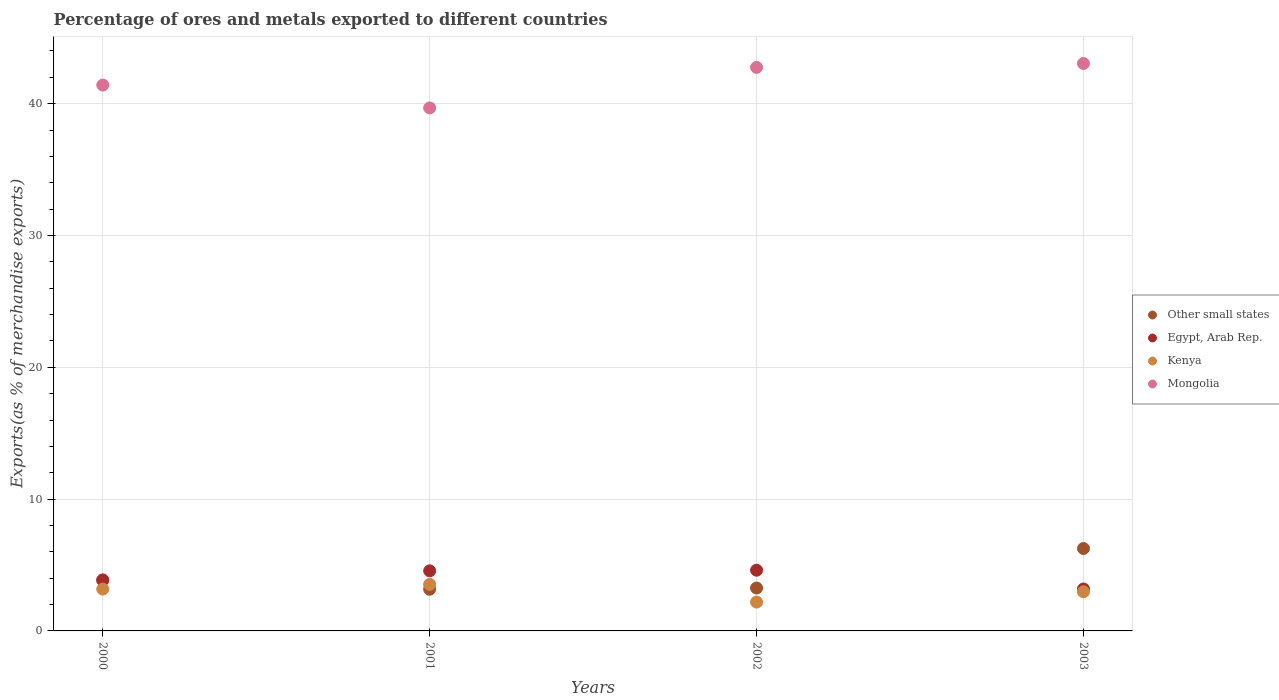Is the number of dotlines equal to the number of legend labels?
Give a very brief answer. Yes. What is the percentage of exports to different countries in Kenya in 2000?
Offer a very short reply. 3.17. Across all years, what is the maximum percentage of exports to different countries in Other small states?
Provide a succinct answer. 6.25. Across all years, what is the minimum percentage of exports to different countries in Egypt, Arab Rep.?
Your answer should be compact. 3.18. In which year was the percentage of exports to different countries in Egypt, Arab Rep. minimum?
Provide a short and direct response. 2003. What is the total percentage of exports to different countries in Other small states in the graph?
Make the answer very short. 16.5. What is the difference between the percentage of exports to different countries in Mongolia in 2002 and that in 2003?
Provide a short and direct response. -0.3. What is the difference between the percentage of exports to different countries in Kenya in 2003 and the percentage of exports to different countries in Egypt, Arab Rep. in 2000?
Provide a succinct answer. -0.9. What is the average percentage of exports to different countries in Mongolia per year?
Ensure brevity in your answer.  41.72. In the year 2002, what is the difference between the percentage of exports to different countries in Egypt, Arab Rep. and percentage of exports to different countries in Mongolia?
Provide a succinct answer. -38.15. In how many years, is the percentage of exports to different countries in Mongolia greater than 4 %?
Offer a terse response. 4. What is the ratio of the percentage of exports to different countries in Kenya in 2002 to that in 2003?
Offer a terse response. 0.74. Is the difference between the percentage of exports to different countries in Egypt, Arab Rep. in 2000 and 2001 greater than the difference between the percentage of exports to different countries in Mongolia in 2000 and 2001?
Give a very brief answer. No. What is the difference between the highest and the second highest percentage of exports to different countries in Egypt, Arab Rep.?
Make the answer very short. 0.05. What is the difference between the highest and the lowest percentage of exports to different countries in Other small states?
Ensure brevity in your answer.  3.09. In how many years, is the percentage of exports to different countries in Egypt, Arab Rep. greater than the average percentage of exports to different countries in Egypt, Arab Rep. taken over all years?
Give a very brief answer. 2. Is the sum of the percentage of exports to different countries in Kenya in 2000 and 2003 greater than the maximum percentage of exports to different countries in Mongolia across all years?
Provide a succinct answer. No. Is it the case that in every year, the sum of the percentage of exports to different countries in Mongolia and percentage of exports to different countries in Kenya  is greater than the sum of percentage of exports to different countries in Other small states and percentage of exports to different countries in Egypt, Arab Rep.?
Offer a terse response. No. Is it the case that in every year, the sum of the percentage of exports to different countries in Other small states and percentage of exports to different countries in Kenya  is greater than the percentage of exports to different countries in Egypt, Arab Rep.?
Your answer should be very brief. Yes. Does the percentage of exports to different countries in Mongolia monotonically increase over the years?
Keep it short and to the point. No. Is the percentage of exports to different countries in Other small states strictly greater than the percentage of exports to different countries in Egypt, Arab Rep. over the years?
Give a very brief answer. No. Does the graph contain grids?
Your answer should be compact. Yes. What is the title of the graph?
Offer a very short reply. Percentage of ores and metals exported to different countries. What is the label or title of the Y-axis?
Your answer should be very brief. Exports(as % of merchandise exports). What is the Exports(as % of merchandise exports) in Other small states in 2000?
Your answer should be very brief. 3.83. What is the Exports(as % of merchandise exports) in Egypt, Arab Rep. in 2000?
Ensure brevity in your answer.  3.87. What is the Exports(as % of merchandise exports) in Kenya in 2000?
Ensure brevity in your answer.  3.17. What is the Exports(as % of merchandise exports) of Mongolia in 2000?
Your answer should be compact. 41.41. What is the Exports(as % of merchandise exports) of Other small states in 2001?
Your response must be concise. 3.16. What is the Exports(as % of merchandise exports) in Egypt, Arab Rep. in 2001?
Keep it short and to the point. 4.56. What is the Exports(as % of merchandise exports) of Kenya in 2001?
Offer a very short reply. 3.53. What is the Exports(as % of merchandise exports) of Mongolia in 2001?
Offer a terse response. 39.68. What is the Exports(as % of merchandise exports) of Other small states in 2002?
Give a very brief answer. 3.25. What is the Exports(as % of merchandise exports) of Egypt, Arab Rep. in 2002?
Make the answer very short. 4.61. What is the Exports(as % of merchandise exports) of Kenya in 2002?
Your answer should be compact. 2.19. What is the Exports(as % of merchandise exports) in Mongolia in 2002?
Make the answer very short. 42.75. What is the Exports(as % of merchandise exports) of Other small states in 2003?
Provide a succinct answer. 6.25. What is the Exports(as % of merchandise exports) of Egypt, Arab Rep. in 2003?
Provide a succinct answer. 3.18. What is the Exports(as % of merchandise exports) of Kenya in 2003?
Ensure brevity in your answer.  2.97. What is the Exports(as % of merchandise exports) of Mongolia in 2003?
Your response must be concise. 43.05. Across all years, what is the maximum Exports(as % of merchandise exports) in Other small states?
Your answer should be compact. 6.25. Across all years, what is the maximum Exports(as % of merchandise exports) in Egypt, Arab Rep.?
Provide a succinct answer. 4.61. Across all years, what is the maximum Exports(as % of merchandise exports) in Kenya?
Provide a succinct answer. 3.53. Across all years, what is the maximum Exports(as % of merchandise exports) of Mongolia?
Offer a terse response. 43.05. Across all years, what is the minimum Exports(as % of merchandise exports) of Other small states?
Give a very brief answer. 3.16. Across all years, what is the minimum Exports(as % of merchandise exports) in Egypt, Arab Rep.?
Offer a terse response. 3.18. Across all years, what is the minimum Exports(as % of merchandise exports) of Kenya?
Provide a short and direct response. 2.19. Across all years, what is the minimum Exports(as % of merchandise exports) of Mongolia?
Keep it short and to the point. 39.68. What is the total Exports(as % of merchandise exports) in Egypt, Arab Rep. in the graph?
Ensure brevity in your answer.  16.22. What is the total Exports(as % of merchandise exports) in Kenya in the graph?
Give a very brief answer. 11.87. What is the total Exports(as % of merchandise exports) in Mongolia in the graph?
Your response must be concise. 166.9. What is the difference between the Exports(as % of merchandise exports) of Other small states in 2000 and that in 2001?
Give a very brief answer. 0.67. What is the difference between the Exports(as % of merchandise exports) of Egypt, Arab Rep. in 2000 and that in 2001?
Your answer should be very brief. -0.69. What is the difference between the Exports(as % of merchandise exports) of Kenya in 2000 and that in 2001?
Offer a terse response. -0.36. What is the difference between the Exports(as % of merchandise exports) in Mongolia in 2000 and that in 2001?
Keep it short and to the point. 1.73. What is the difference between the Exports(as % of merchandise exports) in Other small states in 2000 and that in 2002?
Your answer should be very brief. 0.58. What is the difference between the Exports(as % of merchandise exports) of Egypt, Arab Rep. in 2000 and that in 2002?
Give a very brief answer. -0.73. What is the difference between the Exports(as % of merchandise exports) in Kenya in 2000 and that in 2002?
Make the answer very short. 0.98. What is the difference between the Exports(as % of merchandise exports) of Mongolia in 2000 and that in 2002?
Your answer should be compact. -1.34. What is the difference between the Exports(as % of merchandise exports) of Other small states in 2000 and that in 2003?
Ensure brevity in your answer.  -2.42. What is the difference between the Exports(as % of merchandise exports) in Egypt, Arab Rep. in 2000 and that in 2003?
Offer a very short reply. 0.69. What is the difference between the Exports(as % of merchandise exports) of Kenya in 2000 and that in 2003?
Provide a short and direct response. 0.2. What is the difference between the Exports(as % of merchandise exports) in Mongolia in 2000 and that in 2003?
Your answer should be compact. -1.64. What is the difference between the Exports(as % of merchandise exports) of Other small states in 2001 and that in 2002?
Give a very brief answer. -0.09. What is the difference between the Exports(as % of merchandise exports) in Egypt, Arab Rep. in 2001 and that in 2002?
Offer a very short reply. -0.05. What is the difference between the Exports(as % of merchandise exports) in Kenya in 2001 and that in 2002?
Make the answer very short. 1.34. What is the difference between the Exports(as % of merchandise exports) of Mongolia in 2001 and that in 2002?
Offer a very short reply. -3.07. What is the difference between the Exports(as % of merchandise exports) in Other small states in 2001 and that in 2003?
Provide a succinct answer. -3.09. What is the difference between the Exports(as % of merchandise exports) of Egypt, Arab Rep. in 2001 and that in 2003?
Offer a very short reply. 1.38. What is the difference between the Exports(as % of merchandise exports) in Kenya in 2001 and that in 2003?
Ensure brevity in your answer.  0.56. What is the difference between the Exports(as % of merchandise exports) in Mongolia in 2001 and that in 2003?
Your answer should be very brief. -3.37. What is the difference between the Exports(as % of merchandise exports) in Other small states in 2002 and that in 2003?
Your response must be concise. -3. What is the difference between the Exports(as % of merchandise exports) in Egypt, Arab Rep. in 2002 and that in 2003?
Make the answer very short. 1.42. What is the difference between the Exports(as % of merchandise exports) of Kenya in 2002 and that in 2003?
Offer a terse response. -0.78. What is the difference between the Exports(as % of merchandise exports) of Mongolia in 2002 and that in 2003?
Offer a terse response. -0.3. What is the difference between the Exports(as % of merchandise exports) in Other small states in 2000 and the Exports(as % of merchandise exports) in Egypt, Arab Rep. in 2001?
Provide a short and direct response. -0.73. What is the difference between the Exports(as % of merchandise exports) of Other small states in 2000 and the Exports(as % of merchandise exports) of Kenya in 2001?
Make the answer very short. 0.3. What is the difference between the Exports(as % of merchandise exports) of Other small states in 2000 and the Exports(as % of merchandise exports) of Mongolia in 2001?
Provide a short and direct response. -35.85. What is the difference between the Exports(as % of merchandise exports) in Egypt, Arab Rep. in 2000 and the Exports(as % of merchandise exports) in Kenya in 2001?
Your answer should be compact. 0.34. What is the difference between the Exports(as % of merchandise exports) of Egypt, Arab Rep. in 2000 and the Exports(as % of merchandise exports) of Mongolia in 2001?
Your answer should be compact. -35.81. What is the difference between the Exports(as % of merchandise exports) in Kenya in 2000 and the Exports(as % of merchandise exports) in Mongolia in 2001?
Offer a terse response. -36.51. What is the difference between the Exports(as % of merchandise exports) of Other small states in 2000 and the Exports(as % of merchandise exports) of Egypt, Arab Rep. in 2002?
Provide a succinct answer. -0.78. What is the difference between the Exports(as % of merchandise exports) of Other small states in 2000 and the Exports(as % of merchandise exports) of Kenya in 2002?
Give a very brief answer. 1.64. What is the difference between the Exports(as % of merchandise exports) of Other small states in 2000 and the Exports(as % of merchandise exports) of Mongolia in 2002?
Provide a short and direct response. -38.92. What is the difference between the Exports(as % of merchandise exports) in Egypt, Arab Rep. in 2000 and the Exports(as % of merchandise exports) in Kenya in 2002?
Offer a very short reply. 1.68. What is the difference between the Exports(as % of merchandise exports) in Egypt, Arab Rep. in 2000 and the Exports(as % of merchandise exports) in Mongolia in 2002?
Provide a succinct answer. -38.88. What is the difference between the Exports(as % of merchandise exports) in Kenya in 2000 and the Exports(as % of merchandise exports) in Mongolia in 2002?
Ensure brevity in your answer.  -39.58. What is the difference between the Exports(as % of merchandise exports) of Other small states in 2000 and the Exports(as % of merchandise exports) of Egypt, Arab Rep. in 2003?
Make the answer very short. 0.65. What is the difference between the Exports(as % of merchandise exports) in Other small states in 2000 and the Exports(as % of merchandise exports) in Kenya in 2003?
Give a very brief answer. 0.86. What is the difference between the Exports(as % of merchandise exports) in Other small states in 2000 and the Exports(as % of merchandise exports) in Mongolia in 2003?
Your answer should be compact. -39.22. What is the difference between the Exports(as % of merchandise exports) of Egypt, Arab Rep. in 2000 and the Exports(as % of merchandise exports) of Kenya in 2003?
Make the answer very short. 0.9. What is the difference between the Exports(as % of merchandise exports) of Egypt, Arab Rep. in 2000 and the Exports(as % of merchandise exports) of Mongolia in 2003?
Make the answer very short. -39.18. What is the difference between the Exports(as % of merchandise exports) in Kenya in 2000 and the Exports(as % of merchandise exports) in Mongolia in 2003?
Offer a terse response. -39.88. What is the difference between the Exports(as % of merchandise exports) of Other small states in 2001 and the Exports(as % of merchandise exports) of Egypt, Arab Rep. in 2002?
Make the answer very short. -1.45. What is the difference between the Exports(as % of merchandise exports) of Other small states in 2001 and the Exports(as % of merchandise exports) of Kenya in 2002?
Your answer should be very brief. 0.97. What is the difference between the Exports(as % of merchandise exports) in Other small states in 2001 and the Exports(as % of merchandise exports) in Mongolia in 2002?
Provide a short and direct response. -39.59. What is the difference between the Exports(as % of merchandise exports) in Egypt, Arab Rep. in 2001 and the Exports(as % of merchandise exports) in Kenya in 2002?
Give a very brief answer. 2.37. What is the difference between the Exports(as % of merchandise exports) in Egypt, Arab Rep. in 2001 and the Exports(as % of merchandise exports) in Mongolia in 2002?
Offer a very short reply. -38.2. What is the difference between the Exports(as % of merchandise exports) of Kenya in 2001 and the Exports(as % of merchandise exports) of Mongolia in 2002?
Your answer should be compact. -39.22. What is the difference between the Exports(as % of merchandise exports) in Other small states in 2001 and the Exports(as % of merchandise exports) in Egypt, Arab Rep. in 2003?
Your answer should be compact. -0.02. What is the difference between the Exports(as % of merchandise exports) in Other small states in 2001 and the Exports(as % of merchandise exports) in Kenya in 2003?
Make the answer very short. 0.19. What is the difference between the Exports(as % of merchandise exports) of Other small states in 2001 and the Exports(as % of merchandise exports) of Mongolia in 2003?
Offer a terse response. -39.89. What is the difference between the Exports(as % of merchandise exports) in Egypt, Arab Rep. in 2001 and the Exports(as % of merchandise exports) in Kenya in 2003?
Offer a very short reply. 1.59. What is the difference between the Exports(as % of merchandise exports) of Egypt, Arab Rep. in 2001 and the Exports(as % of merchandise exports) of Mongolia in 2003?
Your response must be concise. -38.49. What is the difference between the Exports(as % of merchandise exports) in Kenya in 2001 and the Exports(as % of merchandise exports) in Mongolia in 2003?
Your answer should be compact. -39.52. What is the difference between the Exports(as % of merchandise exports) in Other small states in 2002 and the Exports(as % of merchandise exports) in Egypt, Arab Rep. in 2003?
Provide a succinct answer. 0.07. What is the difference between the Exports(as % of merchandise exports) in Other small states in 2002 and the Exports(as % of merchandise exports) in Kenya in 2003?
Keep it short and to the point. 0.28. What is the difference between the Exports(as % of merchandise exports) of Other small states in 2002 and the Exports(as % of merchandise exports) of Mongolia in 2003?
Your response must be concise. -39.8. What is the difference between the Exports(as % of merchandise exports) in Egypt, Arab Rep. in 2002 and the Exports(as % of merchandise exports) in Kenya in 2003?
Give a very brief answer. 1.64. What is the difference between the Exports(as % of merchandise exports) in Egypt, Arab Rep. in 2002 and the Exports(as % of merchandise exports) in Mongolia in 2003?
Offer a very short reply. -38.44. What is the difference between the Exports(as % of merchandise exports) of Kenya in 2002 and the Exports(as % of merchandise exports) of Mongolia in 2003?
Your answer should be very brief. -40.86. What is the average Exports(as % of merchandise exports) in Other small states per year?
Make the answer very short. 4.12. What is the average Exports(as % of merchandise exports) in Egypt, Arab Rep. per year?
Your answer should be very brief. 4.06. What is the average Exports(as % of merchandise exports) of Kenya per year?
Keep it short and to the point. 2.97. What is the average Exports(as % of merchandise exports) in Mongolia per year?
Keep it short and to the point. 41.72. In the year 2000, what is the difference between the Exports(as % of merchandise exports) in Other small states and Exports(as % of merchandise exports) in Egypt, Arab Rep.?
Your answer should be compact. -0.04. In the year 2000, what is the difference between the Exports(as % of merchandise exports) in Other small states and Exports(as % of merchandise exports) in Kenya?
Offer a terse response. 0.66. In the year 2000, what is the difference between the Exports(as % of merchandise exports) in Other small states and Exports(as % of merchandise exports) in Mongolia?
Make the answer very short. -37.58. In the year 2000, what is the difference between the Exports(as % of merchandise exports) of Egypt, Arab Rep. and Exports(as % of merchandise exports) of Kenya?
Make the answer very short. 0.7. In the year 2000, what is the difference between the Exports(as % of merchandise exports) of Egypt, Arab Rep. and Exports(as % of merchandise exports) of Mongolia?
Your answer should be very brief. -37.54. In the year 2000, what is the difference between the Exports(as % of merchandise exports) in Kenya and Exports(as % of merchandise exports) in Mongolia?
Make the answer very short. -38.24. In the year 2001, what is the difference between the Exports(as % of merchandise exports) of Other small states and Exports(as % of merchandise exports) of Egypt, Arab Rep.?
Provide a short and direct response. -1.4. In the year 2001, what is the difference between the Exports(as % of merchandise exports) of Other small states and Exports(as % of merchandise exports) of Kenya?
Give a very brief answer. -0.37. In the year 2001, what is the difference between the Exports(as % of merchandise exports) in Other small states and Exports(as % of merchandise exports) in Mongolia?
Your response must be concise. -36.52. In the year 2001, what is the difference between the Exports(as % of merchandise exports) in Egypt, Arab Rep. and Exports(as % of merchandise exports) in Kenya?
Ensure brevity in your answer.  1.03. In the year 2001, what is the difference between the Exports(as % of merchandise exports) of Egypt, Arab Rep. and Exports(as % of merchandise exports) of Mongolia?
Offer a terse response. -35.12. In the year 2001, what is the difference between the Exports(as % of merchandise exports) in Kenya and Exports(as % of merchandise exports) in Mongolia?
Your response must be concise. -36.15. In the year 2002, what is the difference between the Exports(as % of merchandise exports) of Other small states and Exports(as % of merchandise exports) of Egypt, Arab Rep.?
Provide a short and direct response. -1.35. In the year 2002, what is the difference between the Exports(as % of merchandise exports) of Other small states and Exports(as % of merchandise exports) of Kenya?
Offer a terse response. 1.06. In the year 2002, what is the difference between the Exports(as % of merchandise exports) in Other small states and Exports(as % of merchandise exports) in Mongolia?
Provide a short and direct response. -39.5. In the year 2002, what is the difference between the Exports(as % of merchandise exports) in Egypt, Arab Rep. and Exports(as % of merchandise exports) in Kenya?
Offer a very short reply. 2.42. In the year 2002, what is the difference between the Exports(as % of merchandise exports) of Egypt, Arab Rep. and Exports(as % of merchandise exports) of Mongolia?
Offer a very short reply. -38.15. In the year 2002, what is the difference between the Exports(as % of merchandise exports) of Kenya and Exports(as % of merchandise exports) of Mongolia?
Give a very brief answer. -40.56. In the year 2003, what is the difference between the Exports(as % of merchandise exports) in Other small states and Exports(as % of merchandise exports) in Egypt, Arab Rep.?
Ensure brevity in your answer.  3.07. In the year 2003, what is the difference between the Exports(as % of merchandise exports) in Other small states and Exports(as % of merchandise exports) in Kenya?
Provide a short and direct response. 3.28. In the year 2003, what is the difference between the Exports(as % of merchandise exports) of Other small states and Exports(as % of merchandise exports) of Mongolia?
Your response must be concise. -36.8. In the year 2003, what is the difference between the Exports(as % of merchandise exports) of Egypt, Arab Rep. and Exports(as % of merchandise exports) of Kenya?
Keep it short and to the point. 0.21. In the year 2003, what is the difference between the Exports(as % of merchandise exports) of Egypt, Arab Rep. and Exports(as % of merchandise exports) of Mongolia?
Give a very brief answer. -39.87. In the year 2003, what is the difference between the Exports(as % of merchandise exports) in Kenya and Exports(as % of merchandise exports) in Mongolia?
Ensure brevity in your answer.  -40.08. What is the ratio of the Exports(as % of merchandise exports) in Other small states in 2000 to that in 2001?
Your answer should be compact. 1.21. What is the ratio of the Exports(as % of merchandise exports) of Egypt, Arab Rep. in 2000 to that in 2001?
Your answer should be compact. 0.85. What is the ratio of the Exports(as % of merchandise exports) in Kenya in 2000 to that in 2001?
Provide a succinct answer. 0.9. What is the ratio of the Exports(as % of merchandise exports) in Mongolia in 2000 to that in 2001?
Give a very brief answer. 1.04. What is the ratio of the Exports(as % of merchandise exports) of Other small states in 2000 to that in 2002?
Keep it short and to the point. 1.18. What is the ratio of the Exports(as % of merchandise exports) of Egypt, Arab Rep. in 2000 to that in 2002?
Your answer should be compact. 0.84. What is the ratio of the Exports(as % of merchandise exports) of Kenya in 2000 to that in 2002?
Make the answer very short. 1.45. What is the ratio of the Exports(as % of merchandise exports) of Mongolia in 2000 to that in 2002?
Offer a terse response. 0.97. What is the ratio of the Exports(as % of merchandise exports) in Other small states in 2000 to that in 2003?
Your answer should be very brief. 0.61. What is the ratio of the Exports(as % of merchandise exports) in Egypt, Arab Rep. in 2000 to that in 2003?
Ensure brevity in your answer.  1.22. What is the ratio of the Exports(as % of merchandise exports) of Kenya in 2000 to that in 2003?
Give a very brief answer. 1.07. What is the ratio of the Exports(as % of merchandise exports) in Other small states in 2001 to that in 2002?
Provide a succinct answer. 0.97. What is the ratio of the Exports(as % of merchandise exports) of Egypt, Arab Rep. in 2001 to that in 2002?
Offer a very short reply. 0.99. What is the ratio of the Exports(as % of merchandise exports) of Kenya in 2001 to that in 2002?
Your answer should be compact. 1.61. What is the ratio of the Exports(as % of merchandise exports) of Mongolia in 2001 to that in 2002?
Your response must be concise. 0.93. What is the ratio of the Exports(as % of merchandise exports) of Other small states in 2001 to that in 2003?
Provide a short and direct response. 0.51. What is the ratio of the Exports(as % of merchandise exports) of Egypt, Arab Rep. in 2001 to that in 2003?
Provide a succinct answer. 1.43. What is the ratio of the Exports(as % of merchandise exports) of Kenya in 2001 to that in 2003?
Your response must be concise. 1.19. What is the ratio of the Exports(as % of merchandise exports) in Mongolia in 2001 to that in 2003?
Provide a short and direct response. 0.92. What is the ratio of the Exports(as % of merchandise exports) in Other small states in 2002 to that in 2003?
Your answer should be compact. 0.52. What is the ratio of the Exports(as % of merchandise exports) in Egypt, Arab Rep. in 2002 to that in 2003?
Your answer should be very brief. 1.45. What is the ratio of the Exports(as % of merchandise exports) in Kenya in 2002 to that in 2003?
Provide a short and direct response. 0.74. What is the ratio of the Exports(as % of merchandise exports) of Mongolia in 2002 to that in 2003?
Give a very brief answer. 0.99. What is the difference between the highest and the second highest Exports(as % of merchandise exports) in Other small states?
Keep it short and to the point. 2.42. What is the difference between the highest and the second highest Exports(as % of merchandise exports) in Egypt, Arab Rep.?
Provide a succinct answer. 0.05. What is the difference between the highest and the second highest Exports(as % of merchandise exports) of Kenya?
Provide a succinct answer. 0.36. What is the difference between the highest and the second highest Exports(as % of merchandise exports) of Mongolia?
Your answer should be very brief. 0.3. What is the difference between the highest and the lowest Exports(as % of merchandise exports) in Other small states?
Keep it short and to the point. 3.09. What is the difference between the highest and the lowest Exports(as % of merchandise exports) in Egypt, Arab Rep.?
Your answer should be compact. 1.42. What is the difference between the highest and the lowest Exports(as % of merchandise exports) in Kenya?
Your answer should be compact. 1.34. What is the difference between the highest and the lowest Exports(as % of merchandise exports) of Mongolia?
Give a very brief answer. 3.37. 